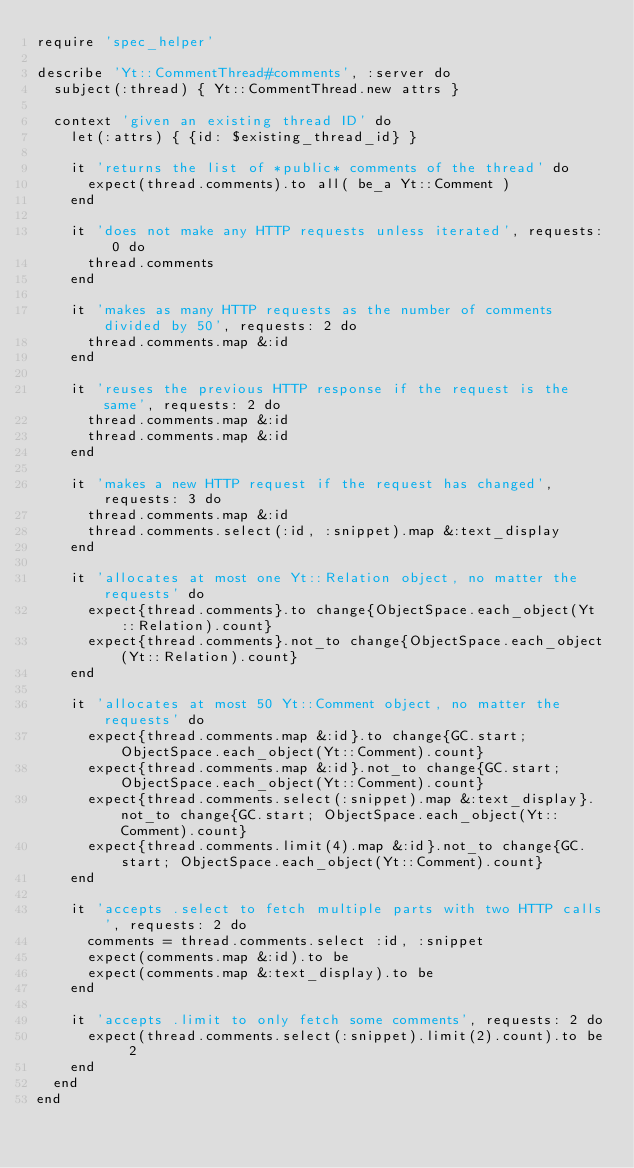Convert code to text. <code><loc_0><loc_0><loc_500><loc_500><_Ruby_>require 'spec_helper'

describe 'Yt::CommentThread#comments', :server do
  subject(:thread) { Yt::CommentThread.new attrs }

  context 'given an existing thread ID' do
    let(:attrs) { {id: $existing_thread_id} }

    it 'returns the list of *public* comments of the thread' do
      expect(thread.comments).to all( be_a Yt::Comment )
    end

    it 'does not make any HTTP requests unless iterated', requests: 0 do
      thread.comments
    end

    it 'makes as many HTTP requests as the number of comments divided by 50', requests: 2 do
      thread.comments.map &:id
    end

    it 'reuses the previous HTTP response if the request is the same', requests: 2 do
      thread.comments.map &:id
      thread.comments.map &:id
    end

    it 'makes a new HTTP request if the request has changed', requests: 3 do
      thread.comments.map &:id
      thread.comments.select(:id, :snippet).map &:text_display
    end

    it 'allocates at most one Yt::Relation object, no matter the requests' do
      expect{thread.comments}.to change{ObjectSpace.each_object(Yt::Relation).count}
      expect{thread.comments}.not_to change{ObjectSpace.each_object(Yt::Relation).count}
    end

    it 'allocates at most 50 Yt::Comment object, no matter the requests' do
      expect{thread.comments.map &:id}.to change{GC.start; ObjectSpace.each_object(Yt::Comment).count}
      expect{thread.comments.map &:id}.not_to change{GC.start; ObjectSpace.each_object(Yt::Comment).count}
      expect{thread.comments.select(:snippet).map &:text_display}.not_to change{GC.start; ObjectSpace.each_object(Yt::Comment).count}
      expect{thread.comments.limit(4).map &:id}.not_to change{GC.start; ObjectSpace.each_object(Yt::Comment).count}
    end

    it 'accepts .select to fetch multiple parts with two HTTP calls', requests: 2 do
      comments = thread.comments.select :id, :snippet
      expect(comments.map &:id).to be
      expect(comments.map &:text_display).to be
    end

    it 'accepts .limit to only fetch some comments', requests: 2 do
      expect(thread.comments.select(:snippet).limit(2).count).to be 2
    end
  end
end
</code> 